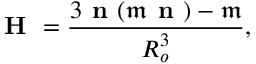<formula> <loc_0><loc_0><loc_500><loc_500>H = \frac { 3 n ( \mathfrak { m } n ) - \mathfrak { m } } { R _ { o } ^ { 3 } } ,</formula> 